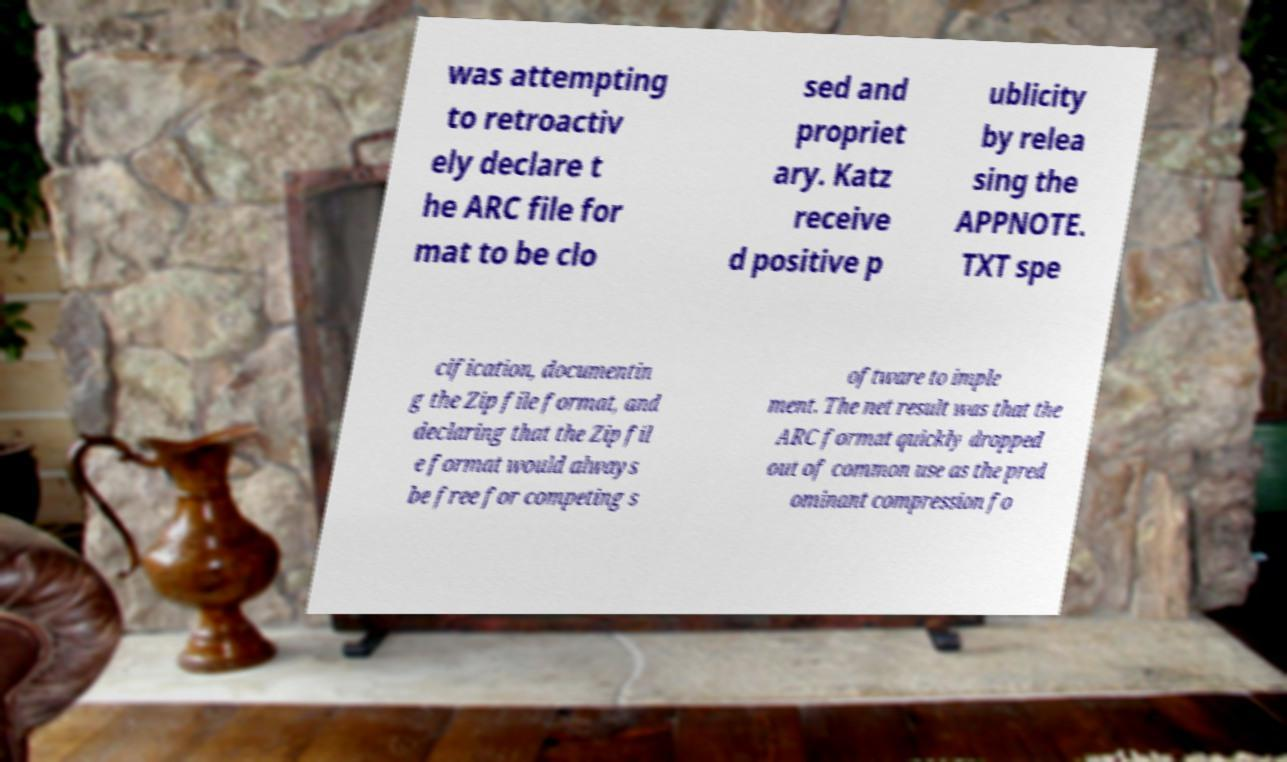Can you accurately transcribe the text from the provided image for me? was attempting to retroactiv ely declare t he ARC file for mat to be clo sed and propriet ary. Katz receive d positive p ublicity by relea sing the APPNOTE. TXT spe cification, documentin g the Zip file format, and declaring that the Zip fil e format would always be free for competing s oftware to imple ment. The net result was that the ARC format quickly dropped out of common use as the pred ominant compression fo 